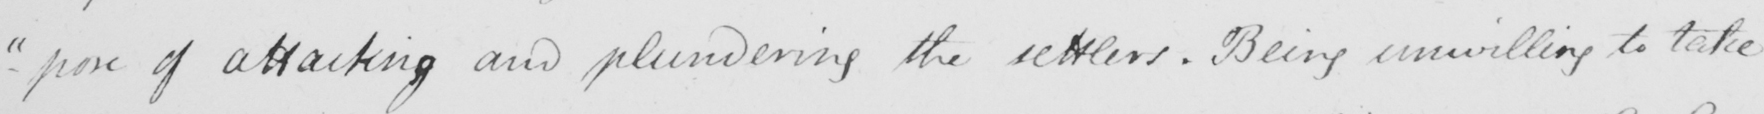Can you tell me what this handwritten text says? - " pose of attacking and plundering the settlers , Being unwilling to take 